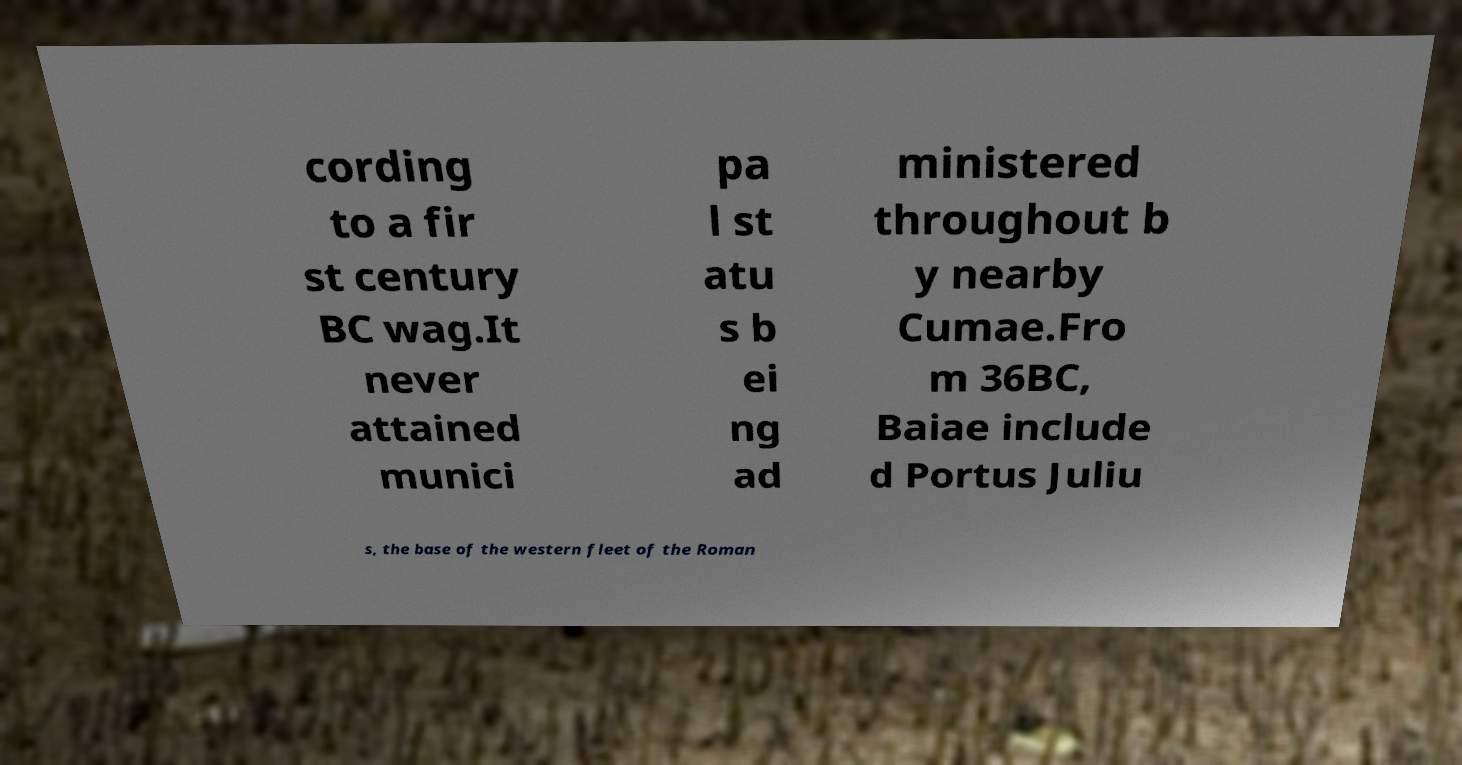Could you assist in decoding the text presented in this image and type it out clearly? cording to a fir st century BC wag.It never attained munici pa l st atu s b ei ng ad ministered throughout b y nearby Cumae.Fro m 36BC, Baiae include d Portus Juliu s, the base of the western fleet of the Roman 